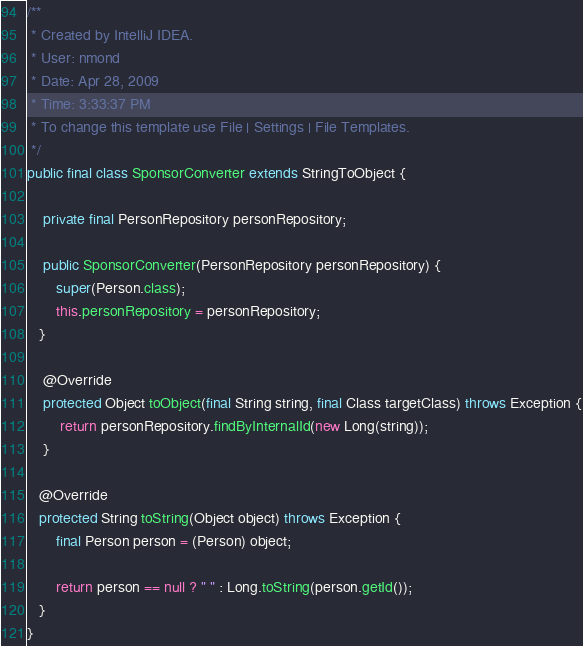<code> <loc_0><loc_0><loc_500><loc_500><_Java_>
/**
 * Created by IntelliJ IDEA.
 * User: nmond
 * Date: Apr 28, 2009
 * Time: 3:33:37 PM
 * To change this template use File | Settings | File Templates.
 */
public final class SponsorConverter extends StringToObject {

    private final PersonRepository personRepository;

    public SponsorConverter(PersonRepository personRepository) {
       super(Person.class);
       this.personRepository = personRepository;
   }

    @Override
    protected Object toObject(final String string, final Class targetClass) throws Exception {
        return personRepository.findByInternalId(new Long(string));
    }

   @Override
   protected String toString(Object object) throws Exception {
       final Person person = (Person) object;

       return person == null ? " " : Long.toString(person.getId());
   }
}</code> 